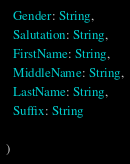<code> <loc_0><loc_0><loc_500><loc_500><_Scala_>  Gender: String,
  Salutation: String,
  FirstName: String,
  MiddleName: String,
  LastName: String,
  Suffix: String
  
)
</code> 